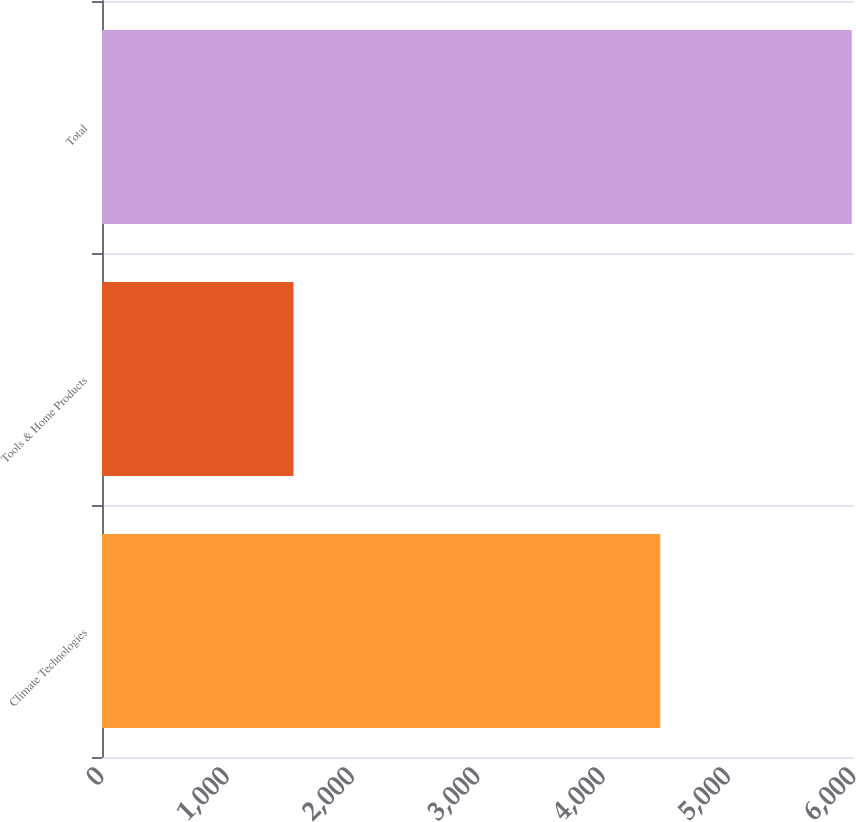<chart> <loc_0><loc_0><loc_500><loc_500><bar_chart><fcel>Climate Technologies<fcel>Tools & Home Products<fcel>Total<nl><fcel>4454<fcel>1528<fcel>5982<nl></chart> 